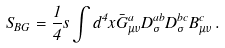Convert formula to latex. <formula><loc_0><loc_0><loc_500><loc_500>S _ { B G } = \frac { 1 } { 4 } s \int d ^ { 4 } x \bar { G } _ { \mu \nu } ^ { a } D _ { \sigma } ^ { a b } D _ { \sigma } ^ { b c } B _ { \mu \nu } ^ { c } \, .</formula> 